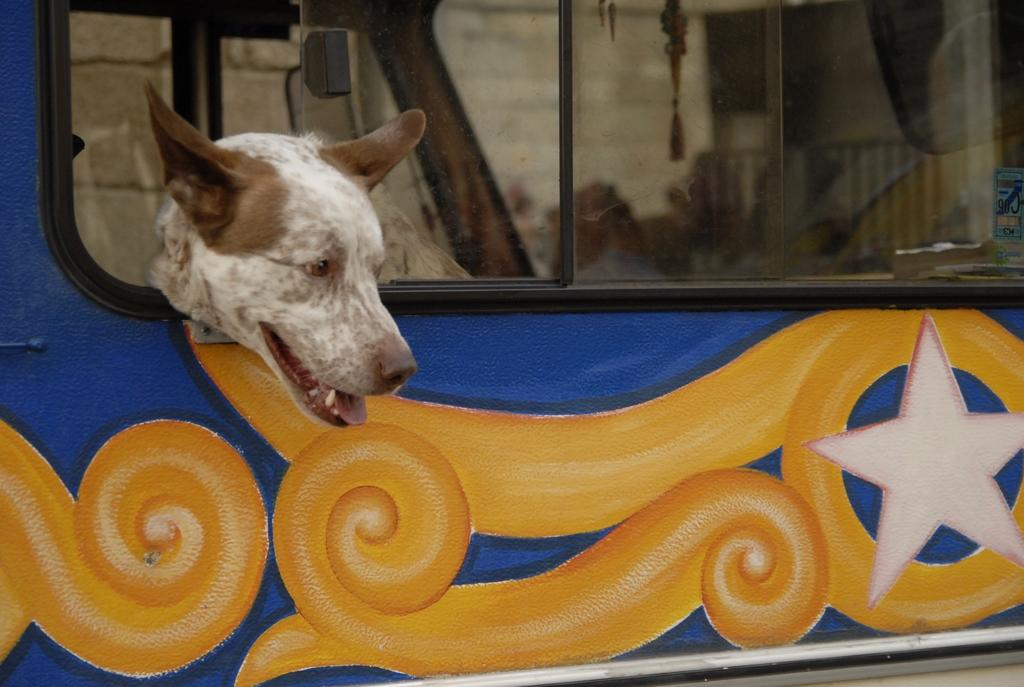What animal can be seen inside the vehicle in the image? There is a dog in the vehicle. What is the dog doing in the image? The dog is keeping its head out of the window of the vehicle. What is visible behind the vehicle in the image? There is a wall behind the vehicle. How is the vehicle decorated in the image? The vehicle has a design painted on it. Can you see any toys scattered around the vehicle in the image? There are no toys visible in the image. Is there a snail crawling on the wall behind the vehicle in the image? There is no snail present in the image. 